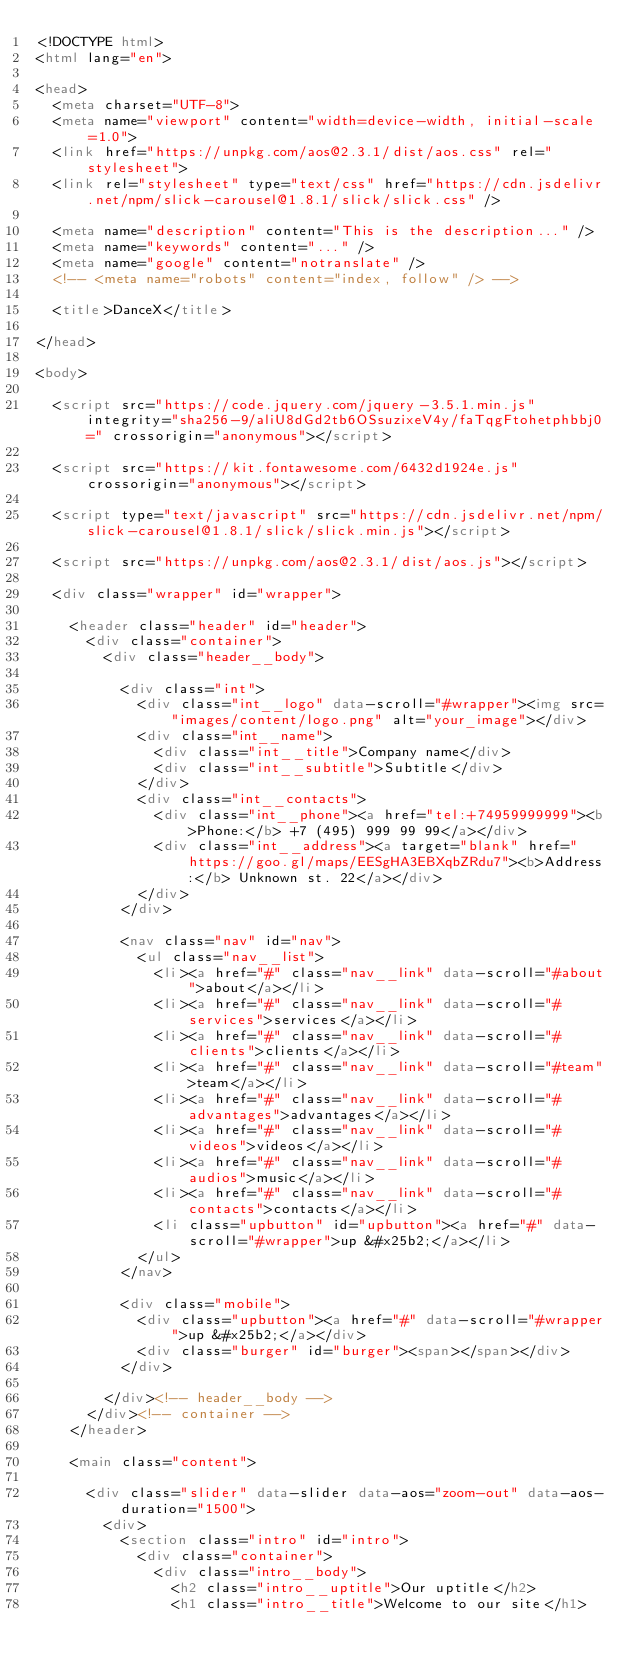<code> <loc_0><loc_0><loc_500><loc_500><_HTML_><!DOCTYPE html>
<html lang="en">

<head>
  <meta charset="UTF-8">
  <meta name="viewport" content="width=device-width, initial-scale=1.0">
  <link href="https://unpkg.com/aos@2.3.1/dist/aos.css" rel="stylesheet">
  <link rel="stylesheet" type="text/css" href="https://cdn.jsdelivr.net/npm/slick-carousel@1.8.1/slick/slick.css" />

  <meta name="description" content="This is the description..." />
  <meta name="keywords" content="..." />
  <meta name="google" content="notranslate" />
  <!-- <meta name="robots" content="index, follow" /> -->

  <title>DanceX</title>

</head>

<body>

  <script src="https://code.jquery.com/jquery-3.5.1.min.js" integrity="sha256-9/aliU8dGd2tb6OSsuzixeV4y/faTqgFtohetphbbj0=" crossorigin="anonymous"></script>

  <script src="https://kit.fontawesome.com/6432d1924e.js" crossorigin="anonymous"></script>

  <script type="text/javascript" src="https://cdn.jsdelivr.net/npm/slick-carousel@1.8.1/slick/slick.min.js"></script>

  <script src="https://unpkg.com/aos@2.3.1/dist/aos.js"></script>

  <div class="wrapper" id="wrapper">

    <header class="header" id="header">
      <div class="container">
        <div class="header__body">

          <div class="int">
            <div class="int__logo" data-scroll="#wrapper"><img src="images/content/logo.png" alt="your_image"></div>
            <div class="int__name">
              <div class="int__title">Company name</div>
              <div class="int__subtitle">Subtitle</div>
            </div>
            <div class="int__contacts">
              <div class="int__phone"><a href="tel:+74959999999"><b>Phone:</b> +7 (495) 999 99 99</a></div>
              <div class="int__address"><a target="blank" href="https://goo.gl/maps/EESgHA3EBXqbZRdu7"><b>Address:</b> Unknown st. 22</a></div>
            </div>
          </div>

          <nav class="nav" id="nav">
            <ul class="nav__list">
              <li><a href="#" class="nav__link" data-scroll="#about">about</a></li>
              <li><a href="#" class="nav__link" data-scroll="#services">services</a></li>
              <li><a href="#" class="nav__link" data-scroll="#clients">clients</a></li>
              <li><a href="#" class="nav__link" data-scroll="#team">team</a></li>
              <li><a href="#" class="nav__link" data-scroll="#advantages">advantages</a></li>
              <li><a href="#" class="nav__link" data-scroll="#videos">videos</a></li>
              <li><a href="#" class="nav__link" data-scroll="#audios">music</a></li>
              <li><a href="#" class="nav__link" data-scroll="#contacts">contacts</a></li>
              <li class="upbutton" id="upbutton"><a href="#" data-scroll="#wrapper">up &#x25b2;</a></li>
            </ul>
          </nav>

          <div class="mobile">
            <div class="upbutton"><a href="#" data-scroll="#wrapper">up &#x25b2;</a></div>
            <div class="burger" id="burger"><span></span></div>
          </div>

        </div><!-- header__body -->
      </div><!-- container -->
    </header>

    <main class="content">

      <div class="slider" data-slider data-aos="zoom-out" data-aos-duration="1500">
        <div>
          <section class="intro" id="intro">
            <div class="container">
              <div class="intro__body">
                <h2 class="intro__uptitle">Our uptitle</h2>
                <h1 class="intro__title">Welcome to our site</h1></code> 